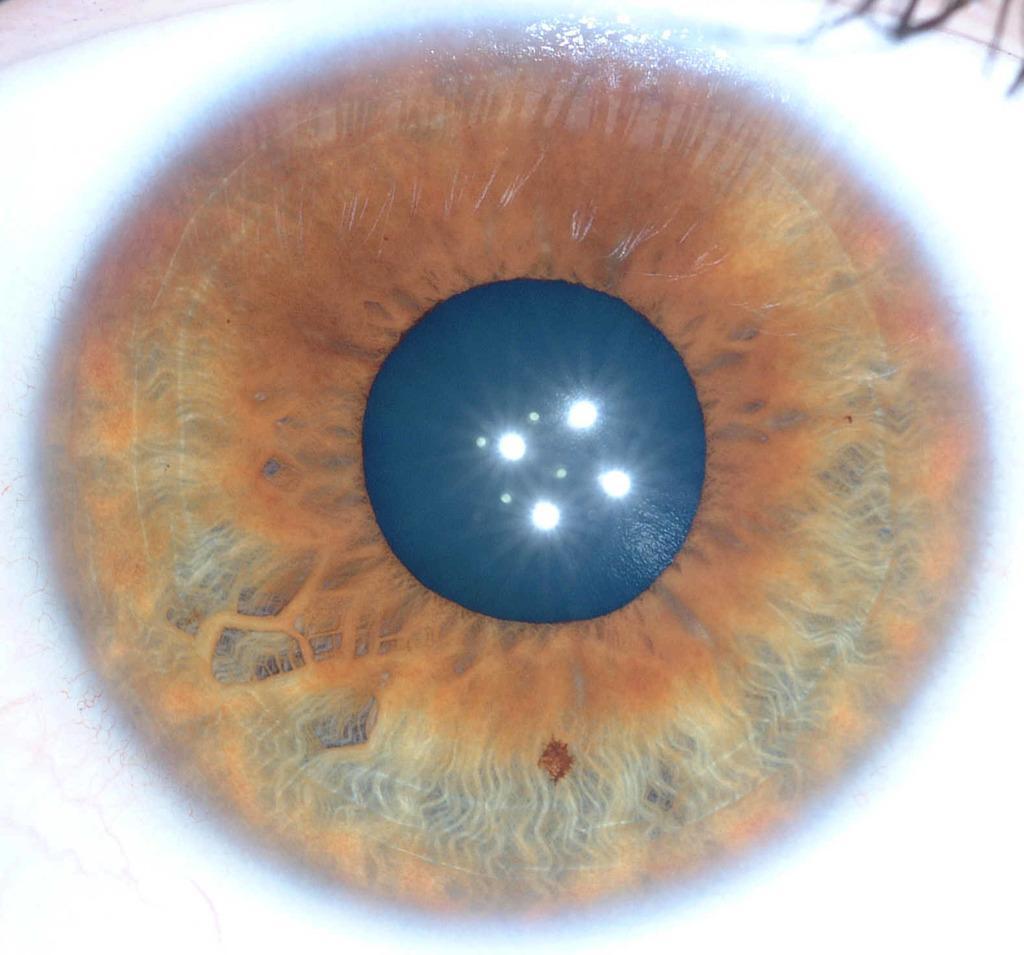Could you give a brief overview of what you see in this image? In this picture I can see an eye. 